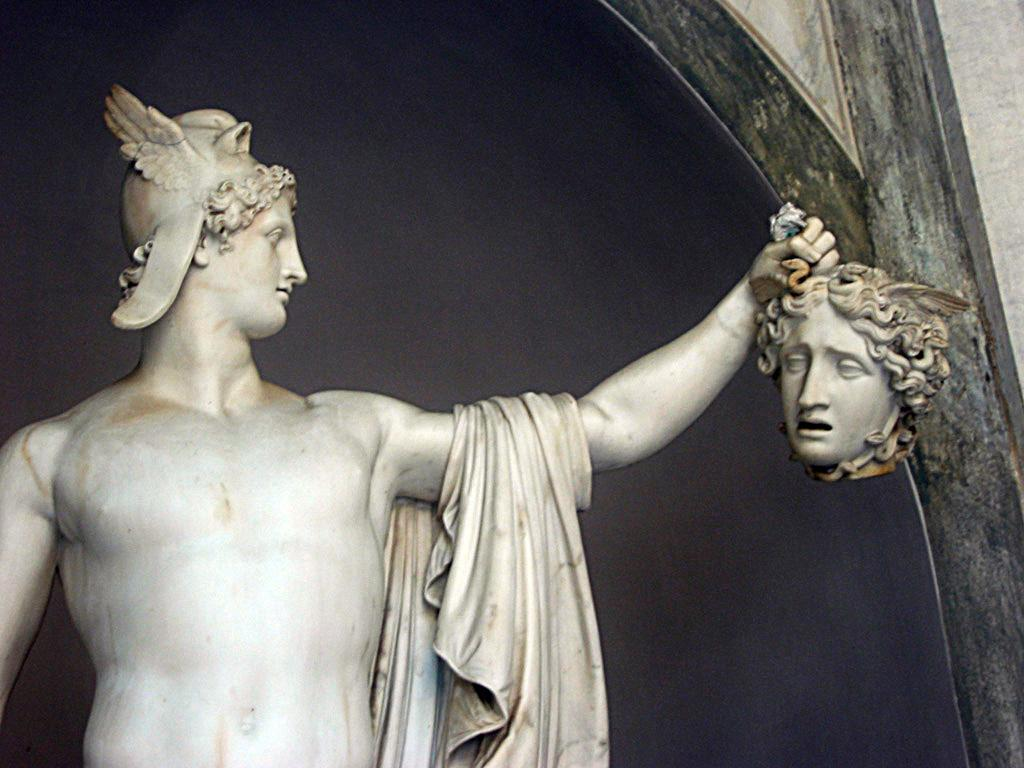What is the main subject of the image? The main subject of the image is a sculpture of a man holding a woman's head. Can you describe the color of the sculpture? The sculpture is white in color. What is located beside the sculpture? There is a wall beside the sculpture. How would you describe the appearance of the wall? The wall has a black shade on it. How many ducks are resting on the sculpture in the image? There are no ducks present in the image; the sculpture features a man holding a woman's head. 